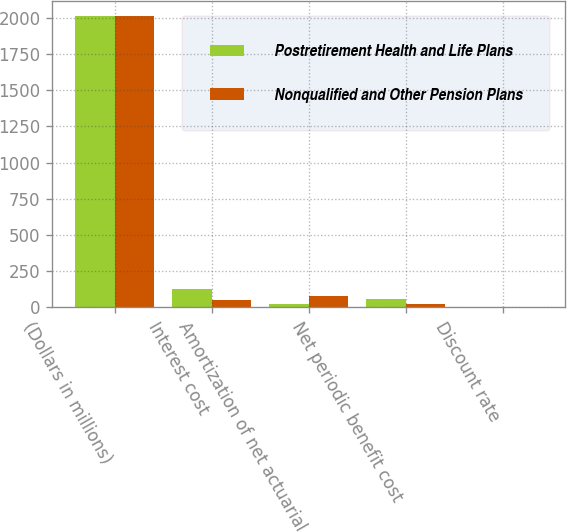Convert chart. <chart><loc_0><loc_0><loc_500><loc_500><stacked_bar_chart><ecel><fcel>(Dollars in millions)<fcel>Interest cost<fcel>Amortization of net actuarial<fcel>Net periodic benefit cost<fcel>Discount rate<nl><fcel>Postretirement Health and Life Plans<fcel>2016<fcel>127<fcel>25<fcel>54<fcel>4.34<nl><fcel>Nonqualified and Other Pension Plans<fcel>2016<fcel>47<fcel>81<fcel>23<fcel>4.32<nl></chart> 